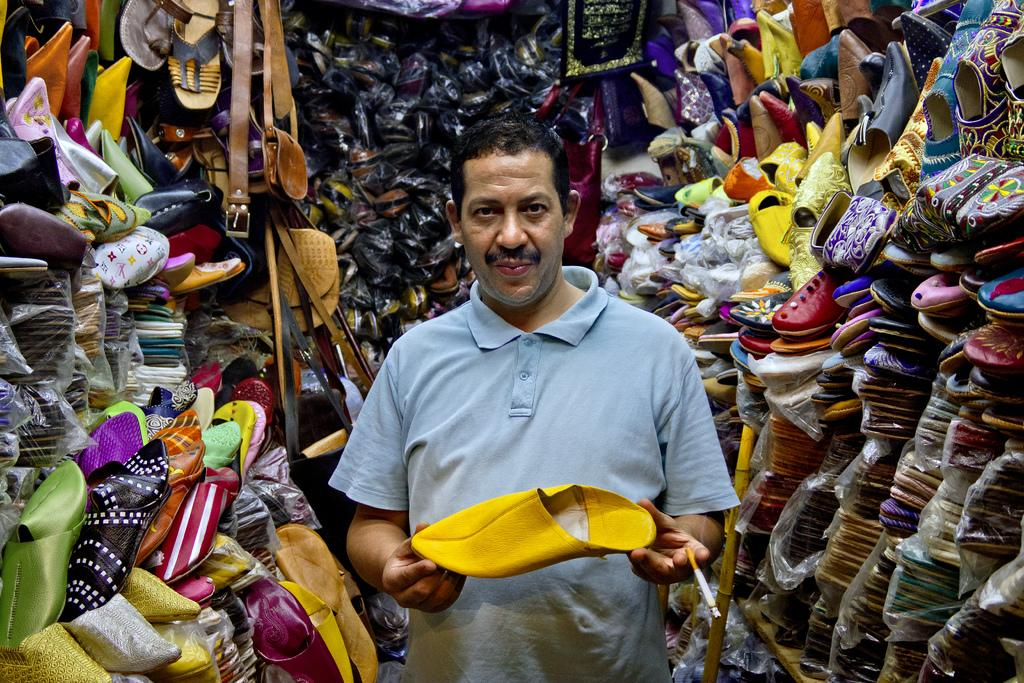Who is present in the image? There is a man in the image. What is the man holding in the image? The man is holding a shoe. What can be seen in the background of the image? There are shoes, bags, and a stick in the background of the image. What type of fowl can be seen in the image? There is no fowl present in the image. What is the value of the bags in the image? The value of the bags cannot be determined from the image alone. 